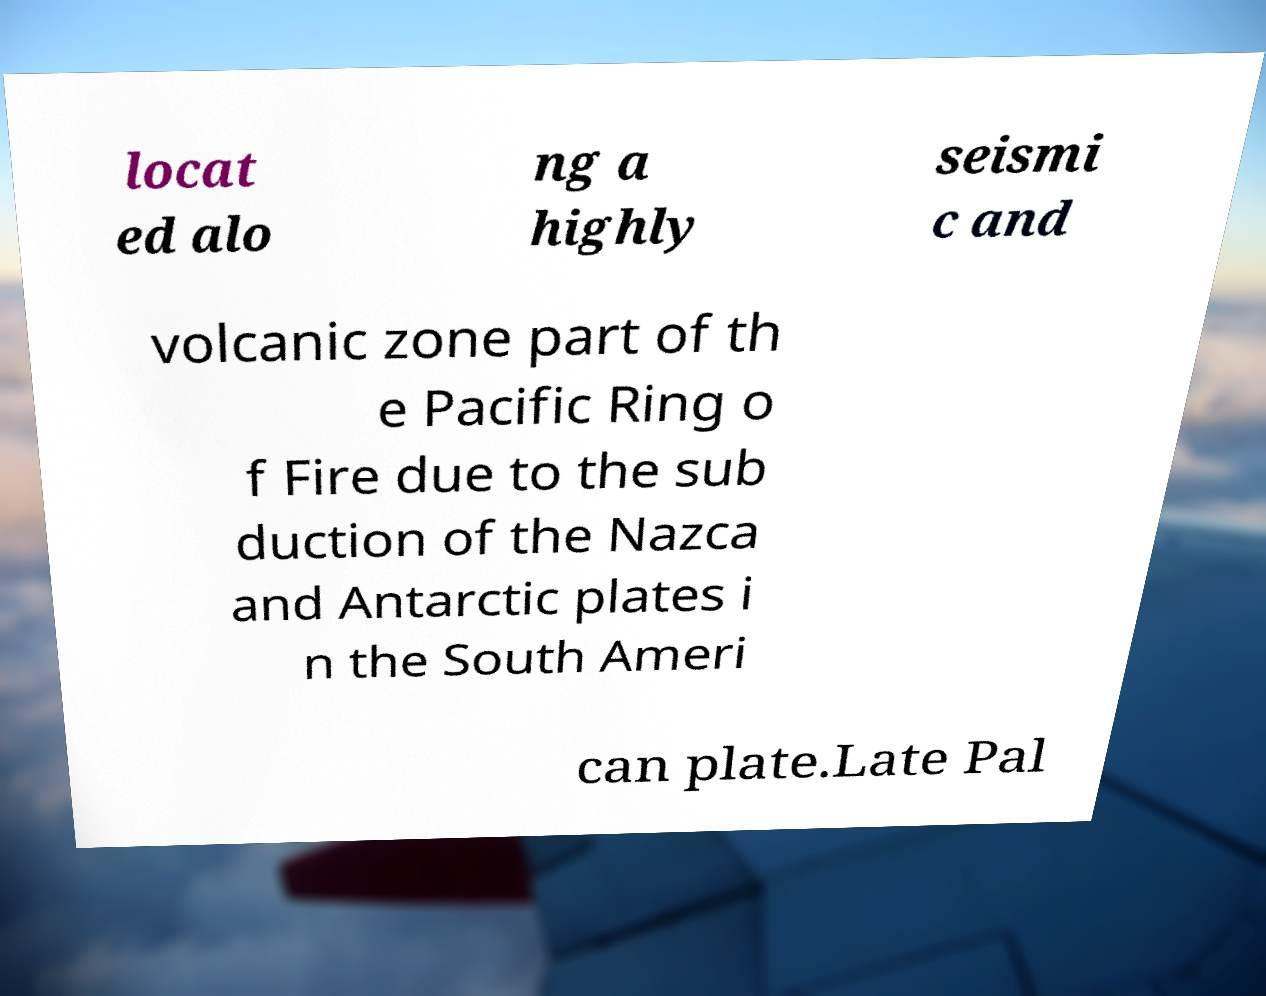What messages or text are displayed in this image? I need them in a readable, typed format. locat ed alo ng a highly seismi c and volcanic zone part of th e Pacific Ring o f Fire due to the sub duction of the Nazca and Antarctic plates i n the South Ameri can plate.Late Pal 